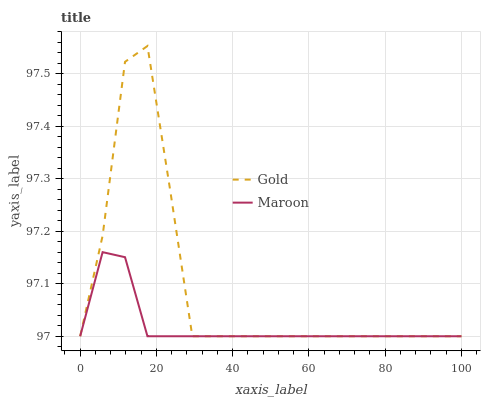Does Maroon have the minimum area under the curve?
Answer yes or no. Yes. Does Gold have the maximum area under the curve?
Answer yes or no. Yes. Does Gold have the minimum area under the curve?
Answer yes or no. No. Is Maroon the smoothest?
Answer yes or no. Yes. Is Gold the roughest?
Answer yes or no. Yes. Is Gold the smoothest?
Answer yes or no. No. 